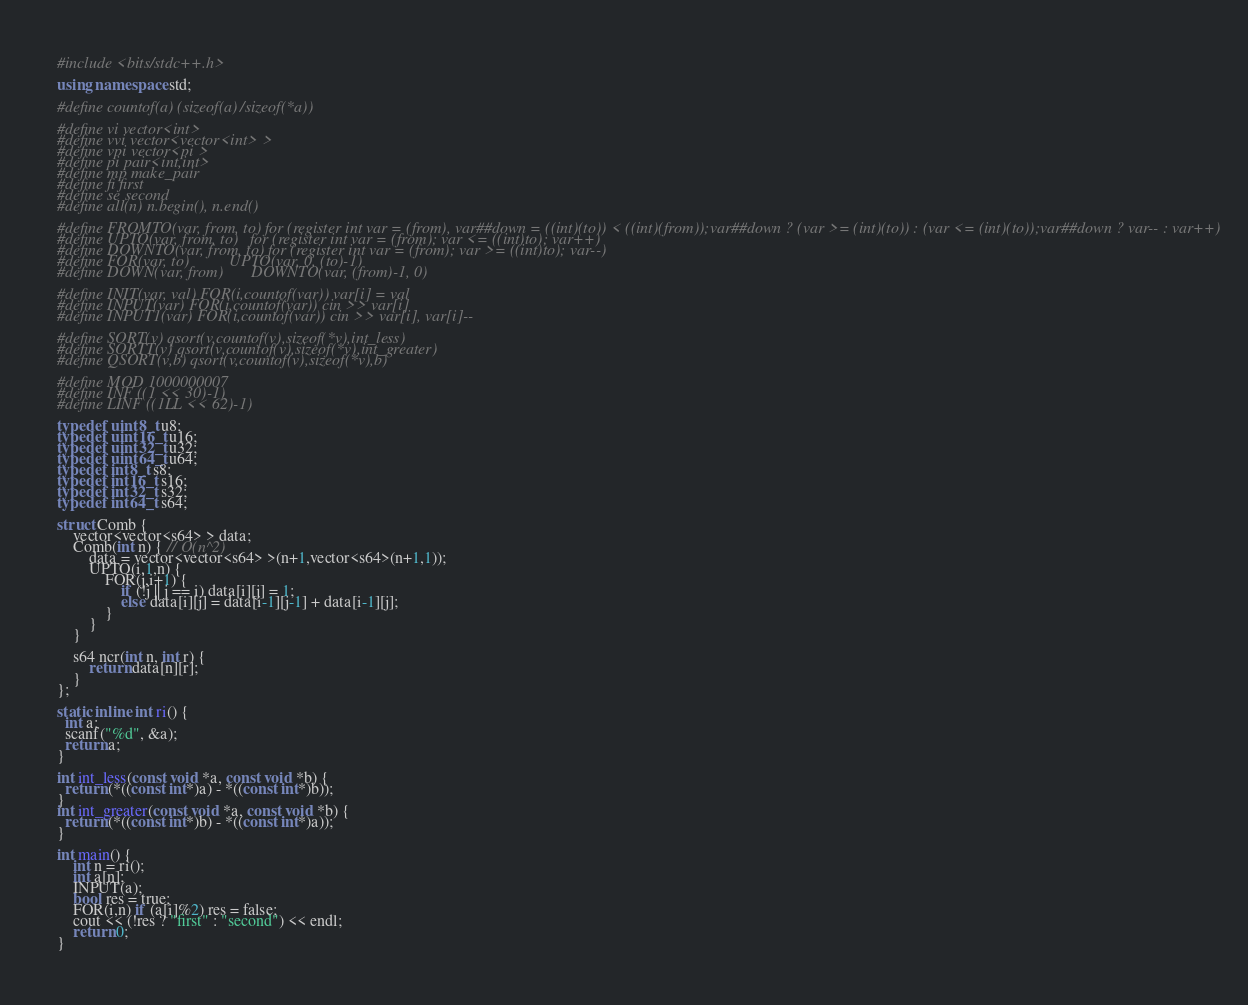Convert code to text. <code><loc_0><loc_0><loc_500><loc_500><_C++_>#include <bits/stdc++.h>

using namespace std;

#define countof(a) (sizeof(a)/sizeof(*a))

#define vi vector<int>
#define vvi vector<vector<int> >
#define vpi vector<pi >
#define pi pair<int,int>
#define mp make_pair
#define fi first
#define se second
#define all(n) n.begin(), n.end()

#define FROMTO(var, from, to) for (register int var = (from), var##down = ((int)(to)) < ((int)(from));var##down ? (var >= (int)(to)) : (var <= (int)(to));var##down ? var-- : var++)
#define UPTO(var, from, to)   for (register int var = (from); var <= ((int)to); var++)
#define DOWNTO(var, from, to) for (register int var = (from); var >= ((int)to); var--)
#define FOR(var, to)          UPTO(var, 0, (to)-1)
#define DOWN(var, from)       DOWNTO(var, (from)-1, 0) 

#define INIT(var, val) FOR(i,countof(var)) var[i] = val
#define INPUT(var) FOR(i,countof(var)) cin >> var[i]
#define INPUT1(var) FOR(i,countof(var)) cin >> var[i], var[i]--

#define SORT(v) qsort(v,countof(v),sizeof(*v),int_less)
#define SORTT(v) qsort(v,countof(v),sizeof(*v),int_greater)
#define QSORT(v,b) qsort(v,countof(v),sizeof(*v),b)

#define MOD 1000000007
#define INF ((1 << 30)-1)
#define LINF ((1LL << 62)-1)

typedef uint8_t u8;
typedef uint16_t u16;
typedef uint32_t u32;
typedef uint64_t u64;
typedef int8_t s8;
typedef int16_t s16;
typedef int32_t s32;
typedef int64_t s64;

struct Comb {
    vector<vector<s64> > data;
    Comb(int n) { // O(n^2)
        data = vector<vector<s64> >(n+1,vector<s64>(n+1,1));
        UPTO(i,1,n) {
            FOR(j,i+1) {
                if (!j || j == i) data[i][j] = 1;
                else data[i][j] = data[i-1][j-1] + data[i-1][j];
            }
        }
    }
    
    s64 ncr(int n, int r) {
        return data[n][r];
    }
};

static inline int ri() {
  int a;
  scanf("%d", &a);
  return a;
}

int int_less(const void *a, const void *b) {
  return (*((const int*)a) - *((const int*)b));
}
int int_greater(const void *a, const void *b) {
  return (*((const int*)b) - *((const int*)a));
}

int main() {
    int n = ri();
	int a[n];
	INPUT(a);
	bool res = true;
	FOR(i,n) if (a[i]%2) res = false;
	cout << (!res ? "first" : "second") << endl;
    return 0;
}
</code> 